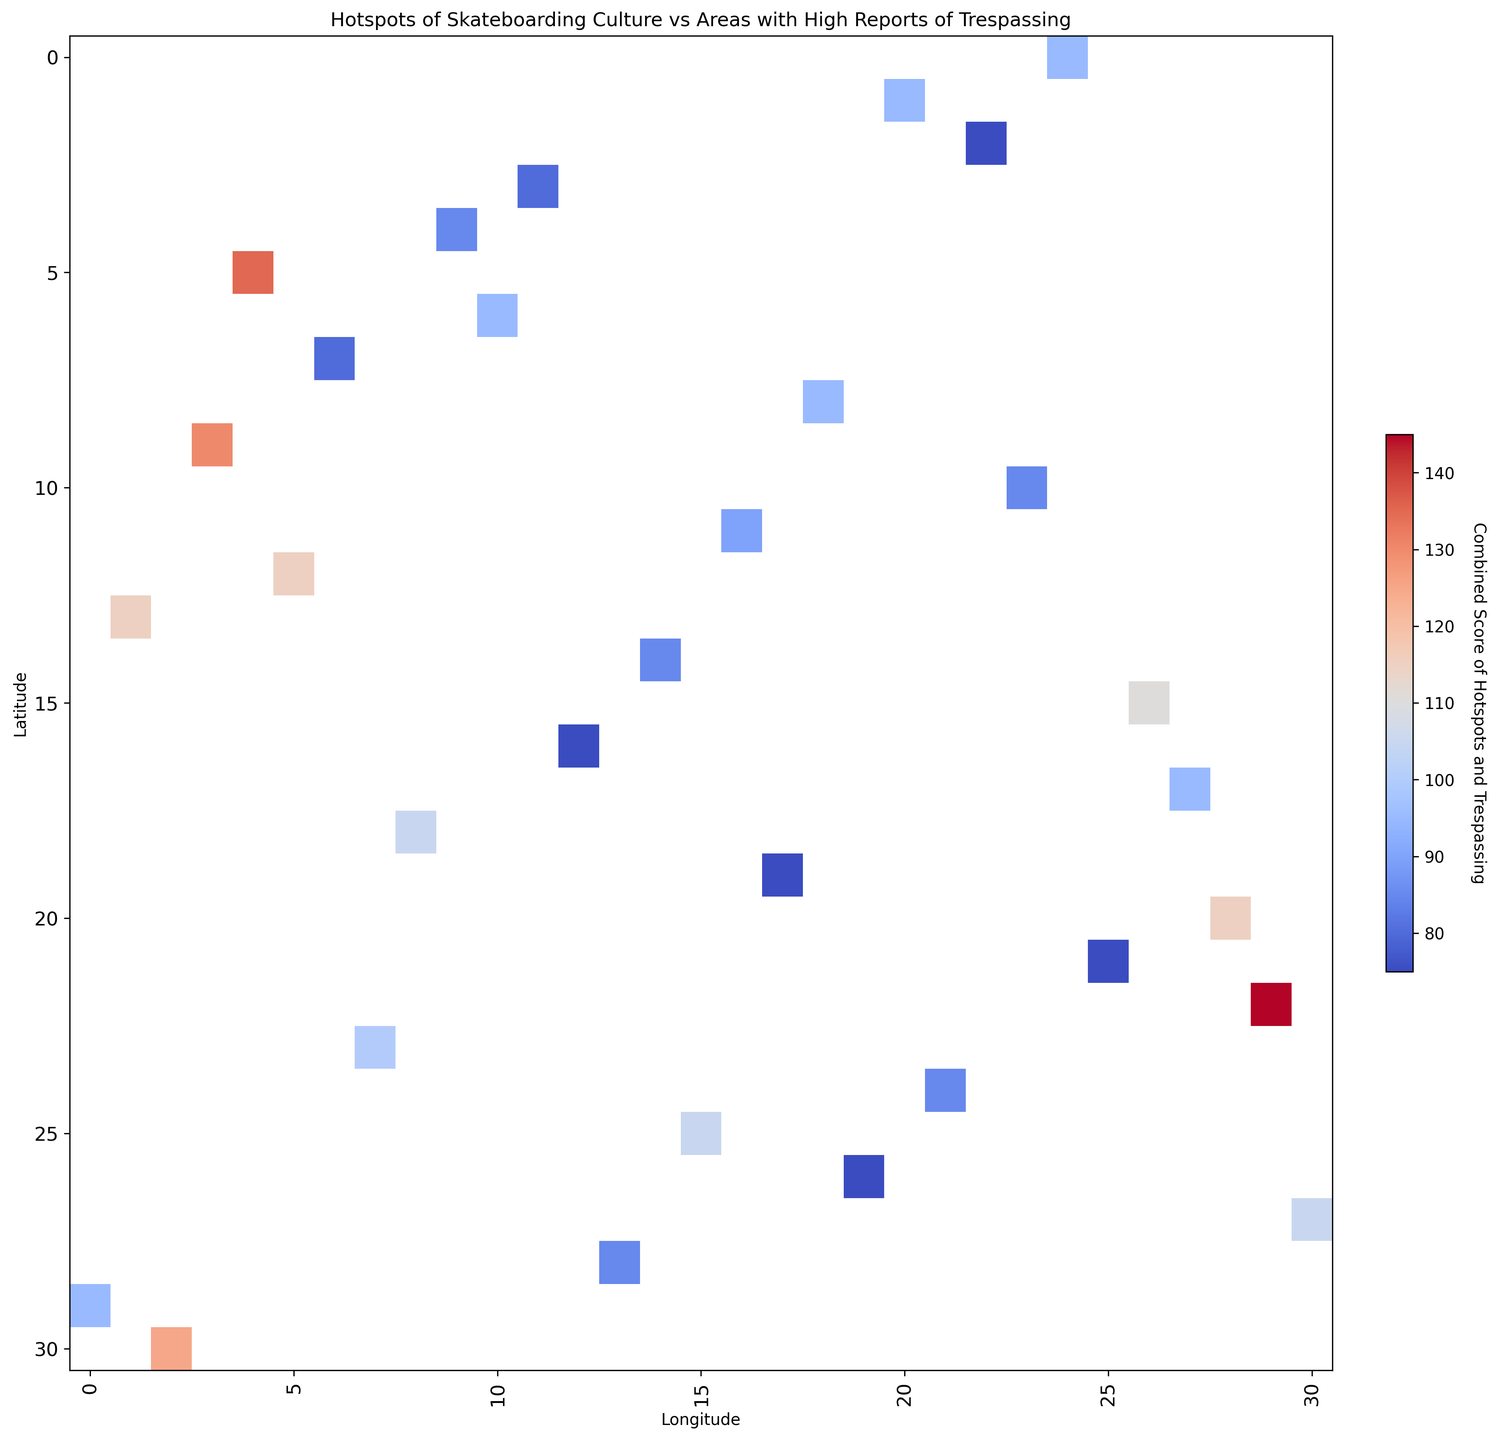Which city has the highest combined score of skateboarding hotspots and reports of trespassing? Look for the city with the most intense color on the heatmap, indicating the highest combined score. The combined data would sum the values from both skateboarding hotspots and trespassing reports.
Answer: New York Compare the combined scores of San Francisco and Denver. Which city has a higher score? Observe the intensity of the colors at the coordinates representing San Francisco and Denver. San Francisco's values (70+45=115) and Denver's values (70+35=105). Compare these results.
Answer: San Francisco What is the average combined score for the cities of Los Angeles, San Francisco, and New York? First, find the combined scores for each city. Los Angeles: 80+50=130, San Francisco: 70+45=115, New York: 90+55=145. Add these together (130+115+145=390) and divide by 3.
Answer: 130 Which cities have an equal combined score for skateboarding hotspots and reports of trespassing? Identify points on the heatmap with the same color intensity and verify the combined values. Cities with the same scores (e.g., 65+35=100 for Chicago and 65+35=100 for Salt Lake City) are equal.
Answer: Chicago, Salt Lake City What is the combined score of Washington D.C., and how does it compare to Boston? Calculate the combined scores: Washington D.C.: 70+40=110, Boston: 60+45=105. Then compare the two calculated values.
Answer: Washington D.C. has a higher score Identify the cities where the combined score is below 70. Check the lighter colored areas on the heatmap and calculate the combined scores. Examples: Phoenix: 55+25=80, not below 70. Look for others.
Answer: None are below 70 Which city shows the least difference between skateboarding hotspots and reports of trespassing? Examine the close-colored data points and compute the differences. For instance, Boston (60-45=15) has a smaller difference compared to others.
Answer: Boston For the central U.S. region, which city has the highest intensity on the heatmap? Focus on the geographic central coordinates (e.g., Kansas City with combined scores). Kansas City values will demonstrate the highest intensity if their score is higher than nearby points.
Answer: Kansas City How do the combined scores of cities in California (Los Angeles, San Francisco, San Diego) compare with each other? Calculate each city's combined score: Los Angeles: 130, San Francisco: 115, San Diego: 135. Order them based on the intensity of colors.
Answer: San Diego > Los Angeles > San Francisco Which city has the lowest combined score and what is that score? Identify the city shaded with the lightest intensity and calculate its combined score (e.g., Orlando: 50+25=75).
Answer: Orlando, 75 